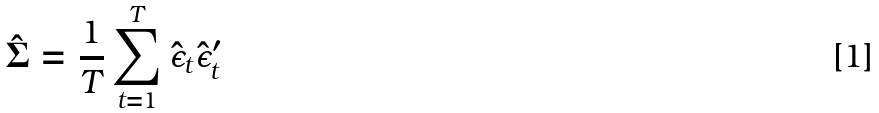<formula> <loc_0><loc_0><loc_500><loc_500>\hat { \Sigma } = \frac { 1 } { T } \sum _ { t = 1 } ^ { T } \hat { \epsilon } _ { t } \hat { \epsilon } _ { t } ^ { \prime }</formula> 